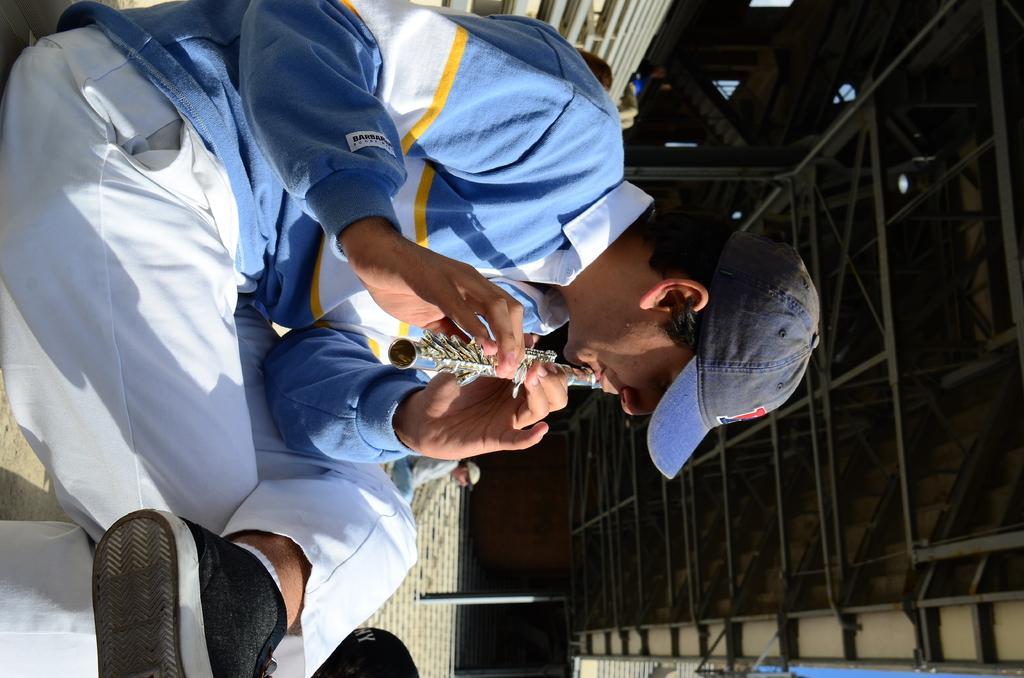Could you give a brief overview of what you see in this image? In this picture, we see a man in the blue T-shirt is sitting and he is wearing a cap. He is holding a musical instrument in his hand. I think he is playing a flute. Beside him, we see a man is sitting. Behind him, we see the poles and the railing. On the right side, we see a pole and the roof of the building. 